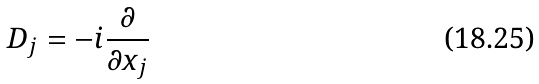Convert formula to latex. <formula><loc_0><loc_0><loc_500><loc_500>D _ { j } = - i \frac { \partial } { \partial x _ { j } }</formula> 